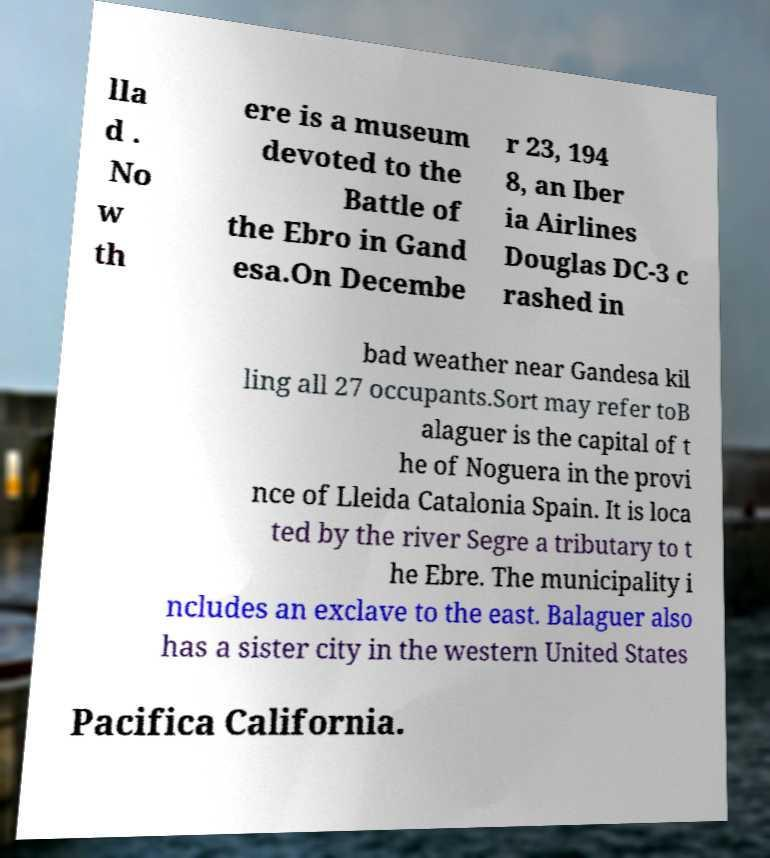Could you assist in decoding the text presented in this image and type it out clearly? lla d . No w th ere is a museum devoted to the Battle of the Ebro in Gand esa.On Decembe r 23, 194 8, an Iber ia Airlines Douglas DC-3 c rashed in bad weather near Gandesa kil ling all 27 occupants.Sort may refer toB alaguer is the capital of t he of Noguera in the provi nce of Lleida Catalonia Spain. It is loca ted by the river Segre a tributary to t he Ebre. The municipality i ncludes an exclave to the east. Balaguer also has a sister city in the western United States Pacifica California. 